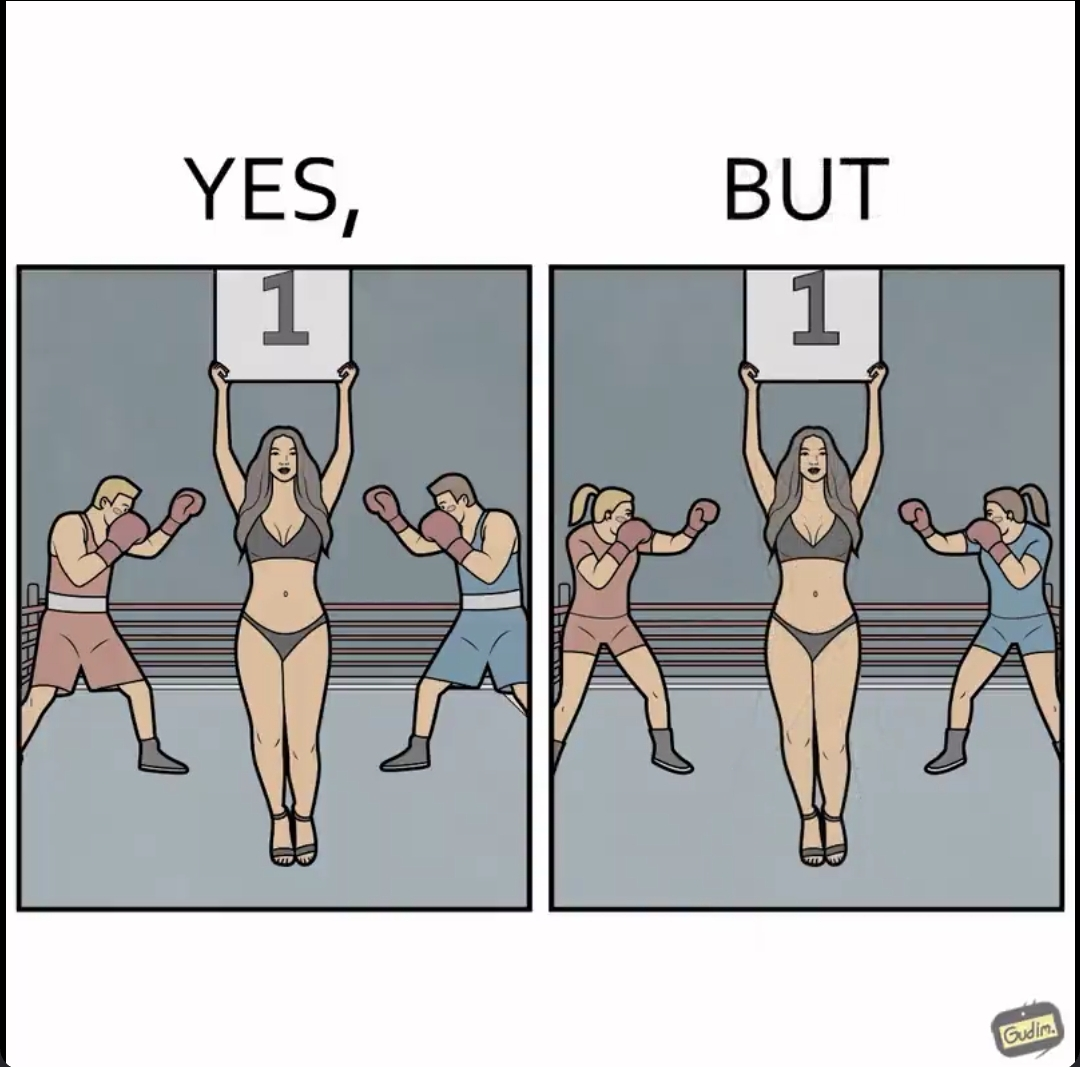Describe what you see in this image. The images are ironic since it shows how women are represented in our society. When it comes to a men's boxing match, a woman in revealing clothes is expected to hold out boards depicting round numbers but in a women's boxing match, they do not expect men to do so. It is poking fun at the gender roles that exist in our society 